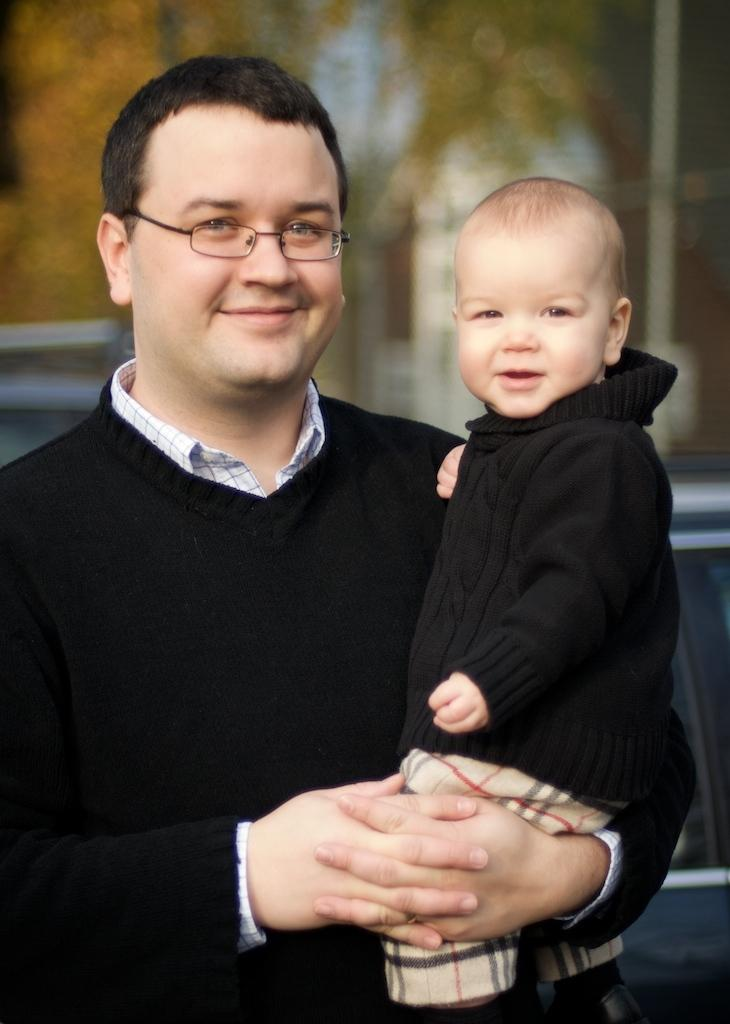Who is in the image? There is a man in the image. What is the man doing in the image? The man is holding a baby. How are the man and the baby feeling in the image? Both the man and the baby are smiling. What are the man and the baby wearing in the image? The man and the baby are wearing black dresses. What can be seen in the background of the image? There are trees visible in the background of the image, although they are not clearly visible. What type of attraction is the man and baby visiting in the image? There is no indication of an attraction in the image; it simply shows a man holding a baby. Can you see any zebras in the image? No, there are no zebras present in the image. 